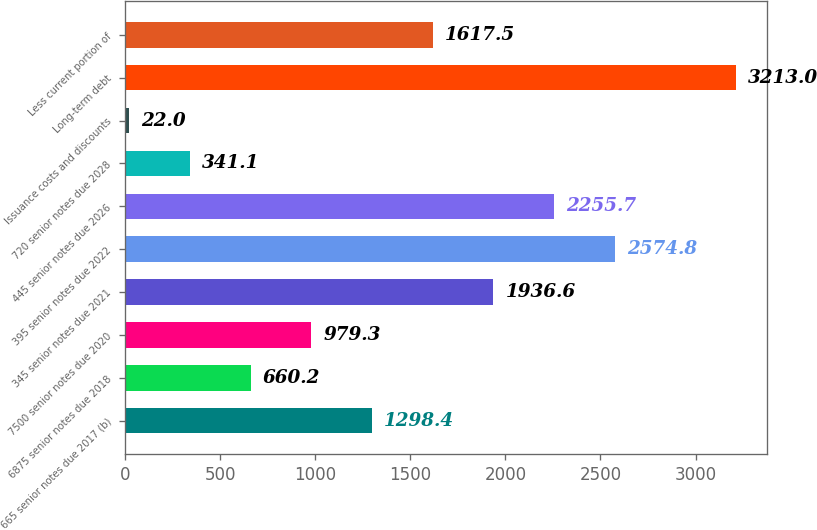<chart> <loc_0><loc_0><loc_500><loc_500><bar_chart><fcel>665 senior notes due 2017 (b)<fcel>6875 senior notes due 2018<fcel>7500 senior notes due 2020<fcel>345 senior notes due 2021<fcel>395 senior notes due 2022<fcel>445 senior notes due 2026<fcel>720 senior notes due 2028<fcel>Issuance costs and discounts<fcel>Long-term debt<fcel>Less current portion of<nl><fcel>1298.4<fcel>660.2<fcel>979.3<fcel>1936.6<fcel>2574.8<fcel>2255.7<fcel>341.1<fcel>22<fcel>3213<fcel>1617.5<nl></chart> 